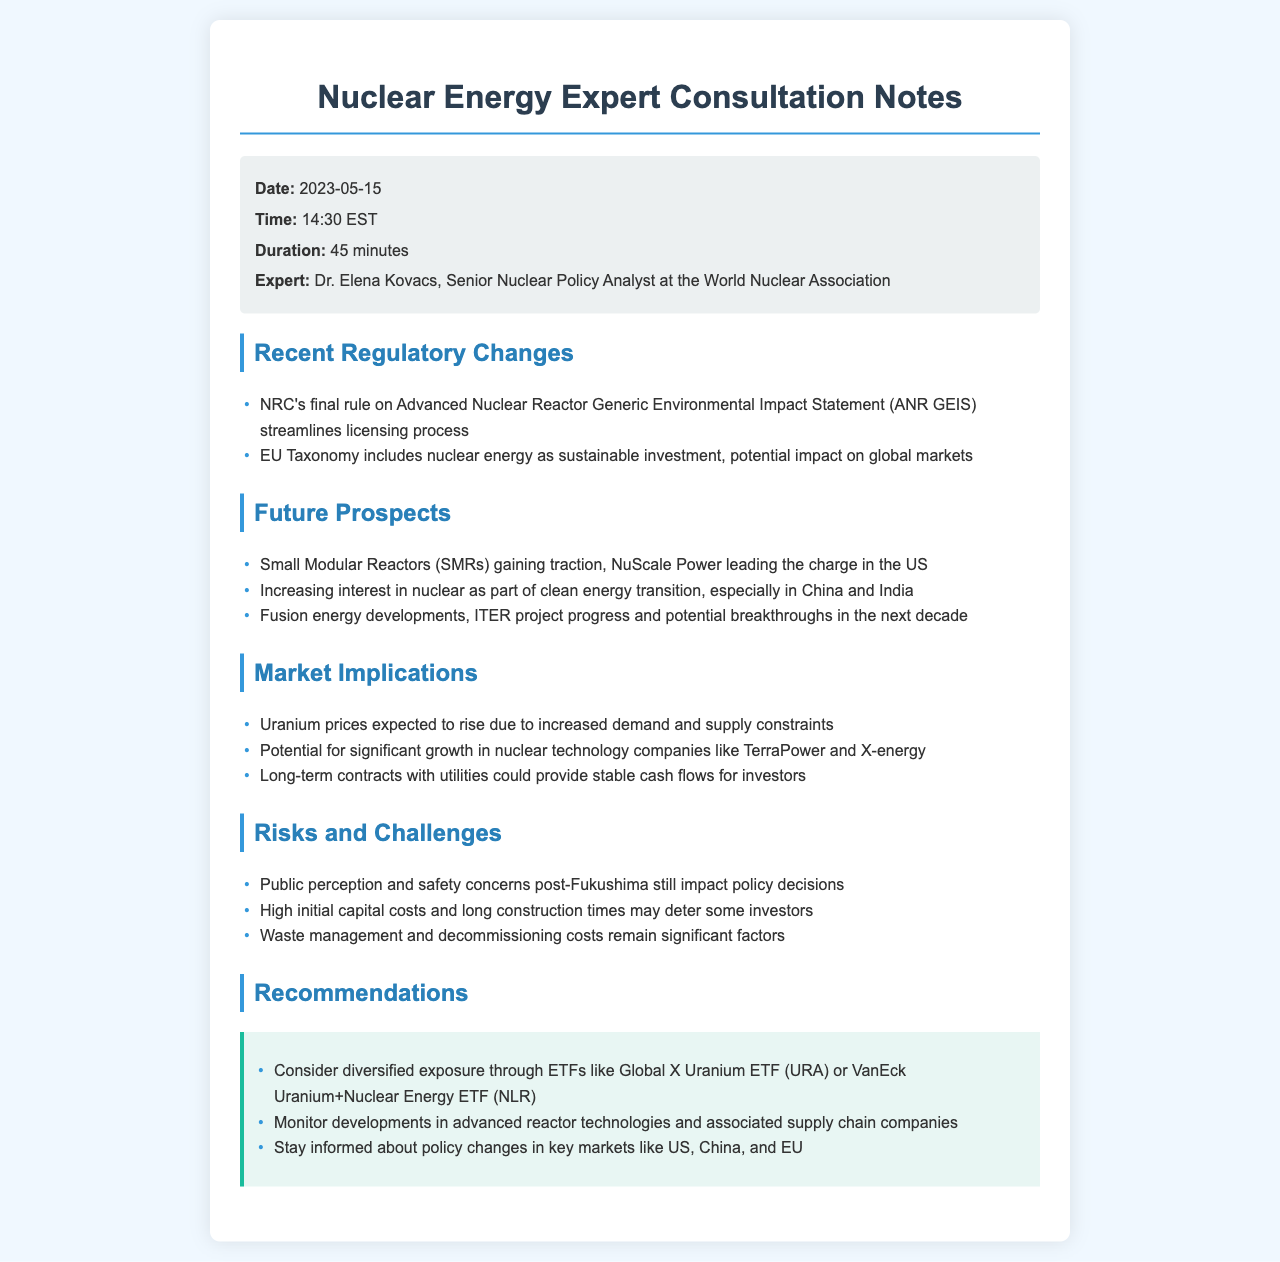What is the date of the consultation? The date is specifically provided in the call details section of the document.
Answer: 2023-05-15 Who is the expert consulted in this document? The expert's name is highlighted in the call details, indicating their position and affiliation.
Answer: Dr. Elena Kovacs What rule was discussed regarding the licensing process? The document mentions a specific rule under Recent Regulatory Changes that pertains to the licensing process.
Answer: Advanced Nuclear Reactor Generic Environmental Impact Statement (ANR GEIS) Which company is leading the charge in Small Modular Reactors in the US? The document specifies a company that is currently prominent in the development of SMRs, found in the Future Prospects section.
Answer: NuScale Power What is expected to happen to uranium prices? The market implications section indicates a trend regarding uranium prices due to certain demand factors.
Answer: Expected to rise What are the long-term cash flow prospects for investors in nuclear technology? This information is found in the Market Implications section, tying investment strategies to projected contracts.
Answer: Stable cash flows What significant challenge is linked to public perception? Safety concerns stemming from historical events are mentioned as a factor influencing policy decisions in the Risks and Challenges section.
Answer: Public perception and safety concerns post-Fukushima Which ETFs are recommended for diversified exposure? In the recommendations section, specific ETFs are suggested for investment, indicating a strategy for engagement in the market.
Answer: Global X Uranium ETF (URA) or VanEck Uranium+Nuclear Energy ETF (NLR) What is a potential breakthrough mentioned in the future prospects? The document discusses progress in a particular project within fusion energy developments as a future breakthrough.
Answer: ITER project progress 